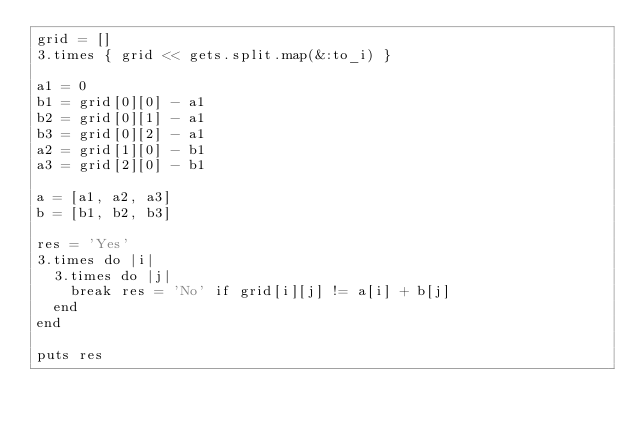<code> <loc_0><loc_0><loc_500><loc_500><_Ruby_>grid = []
3.times { grid << gets.split.map(&:to_i) }

a1 = 0
b1 = grid[0][0] - a1
b2 = grid[0][1] - a1
b3 = grid[0][2] - a1
a2 = grid[1][0] - b1
a3 = grid[2][0] - b1

a = [a1, a2, a3]
b = [b1, b2, b3]

res = 'Yes'
3.times do |i|
  3.times do |j|
    break res = 'No' if grid[i][j] != a[i] + b[j]
  end
end

puts res
</code> 